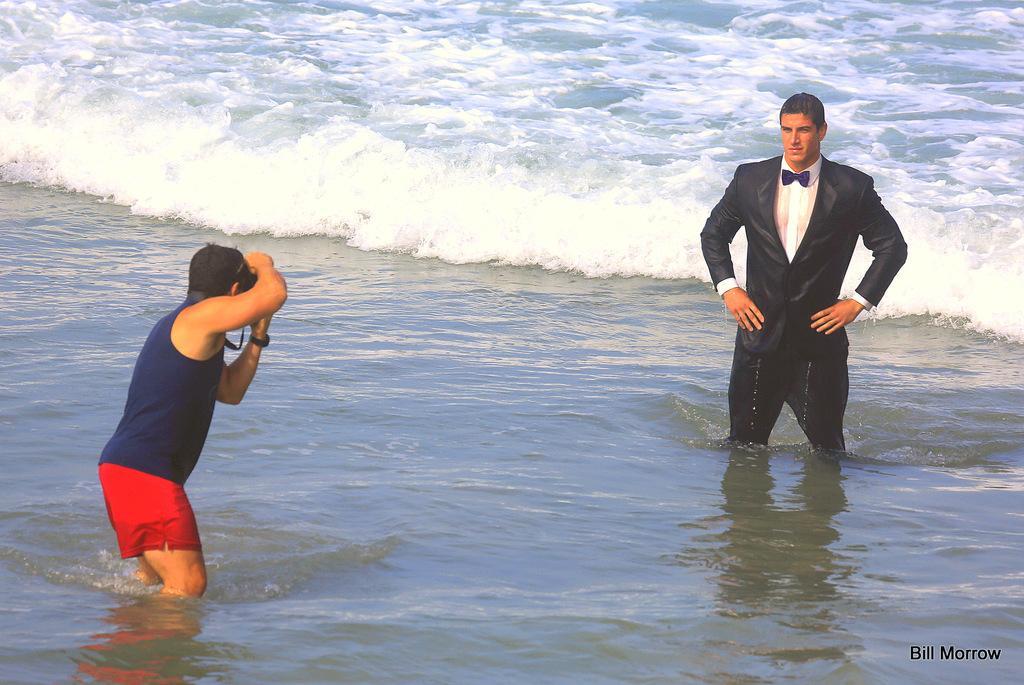Could you give a brief overview of what you see in this image? In this image there is a person standing in the water is clicking the picture of another person in front of him in the water, behind them there are waves. 